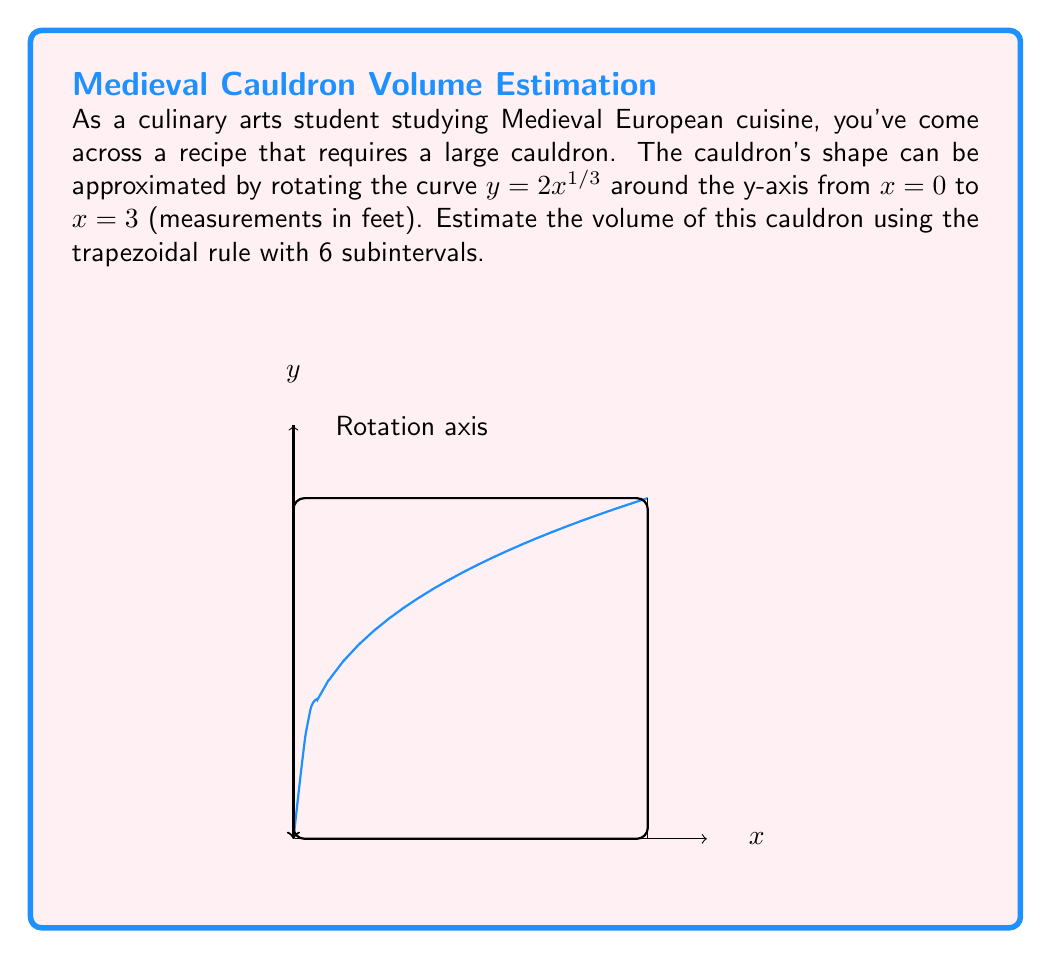Teach me how to tackle this problem. Let's approach this step-by-step:

1) The volume of a solid of revolution is given by the formula:

   $$V = \pi \int_a^b [f(x)]^2 dx$$

   Here, $f(x) = 2x^{1/3}$, $a = 0$, and $b = 3$.

2) Our integral becomes:

   $$V = \pi \int_0^3 (2x^{1/3})^2 dx = 4\pi \int_0^3 x^{2/3} dx$$

3) To use the trapezoidal rule with 6 subintervals, we need to divide the interval $[0, 3]$ into 6 equal parts. The width of each subinterval is:

   $$\Delta x = \frac{3-0}{6} = 0.5$$

4) The x-values for our trapezoids will be:
   $x_0 = 0$, $x_1 = 0.5$, $x_2 = 1$, $x_3 = 1.5$, $x_4 = 2$, $x_5 = 2.5$, $x_6 = 3$

5) The trapezoidal rule formula is:

   $$\int_a^b f(x)dx \approx \frac{\Delta x}{2}[f(x_0) + 2f(x_1) + 2f(x_2) + ... + 2f(x_{n-1}) + f(x_n)]$$

6) Applying this to our function $4\pi x^{2/3}$:

   $$V \approx 4\pi \cdot \frac{0.5}{2}[(0^{2/3} + 3^{2/3}) + 2(0.5^{2/3} + 1^{2/3} + 1.5^{2/3} + 2^{2/3} + 2.5^{2/3})]$$

7) Calculating the values:

   $$V \approx 2\pi[0 + 2.08 + 2(0.63 + 1 + 1.31 + 1.59 + 1.84)]$$
   $$V \approx 2\pi[2.08 + 12.74] = 2\pi(14.82) \approx 93.17$$

Therefore, the estimated volume of the cauldron is approximately 93.17 cubic feet.
Answer: $93.17$ cubic feet 